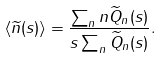<formula> <loc_0><loc_0><loc_500><loc_500>\langle \widetilde { n } ( s ) \rangle = \frac { \sum _ { n } n \widetilde { Q } _ { n } ( s ) } { s \sum _ { n } \widetilde { Q } _ { n } ( s ) } .</formula> 